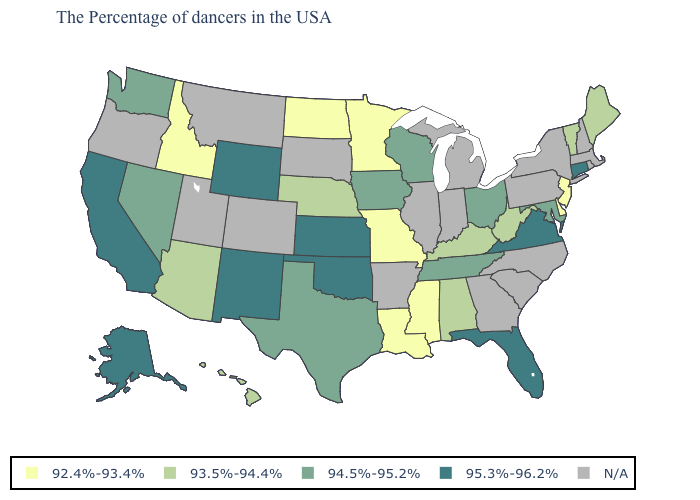What is the value of Texas?
Give a very brief answer. 94.5%-95.2%. What is the lowest value in the USA?
Keep it brief. 92.4%-93.4%. Which states have the lowest value in the USA?
Concise answer only. New Jersey, Delaware, Mississippi, Louisiana, Missouri, Minnesota, North Dakota, Idaho. What is the highest value in the USA?
Concise answer only. 95.3%-96.2%. Which states have the highest value in the USA?
Keep it brief. Connecticut, Virginia, Florida, Kansas, Oklahoma, Wyoming, New Mexico, California, Alaska. Name the states that have a value in the range 92.4%-93.4%?
Write a very short answer. New Jersey, Delaware, Mississippi, Louisiana, Missouri, Minnesota, North Dakota, Idaho. What is the value of Alaska?
Write a very short answer. 95.3%-96.2%. Name the states that have a value in the range 92.4%-93.4%?
Keep it brief. New Jersey, Delaware, Mississippi, Louisiana, Missouri, Minnesota, North Dakota, Idaho. Is the legend a continuous bar?
Write a very short answer. No. What is the value of Indiana?
Concise answer only. N/A. Name the states that have a value in the range 92.4%-93.4%?
Short answer required. New Jersey, Delaware, Mississippi, Louisiana, Missouri, Minnesota, North Dakota, Idaho. Among the states that border New Jersey , which have the highest value?
Give a very brief answer. Delaware. What is the value of Massachusetts?
Quick response, please. N/A. 